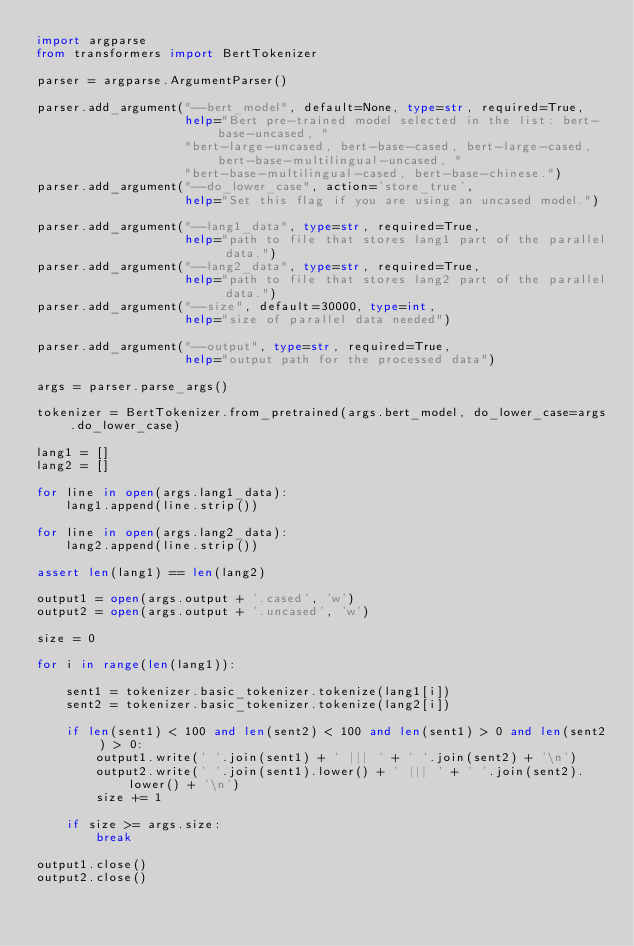Convert code to text. <code><loc_0><loc_0><loc_500><loc_500><_Python_>import argparse
from transformers import BertTokenizer

parser = argparse.ArgumentParser()

parser.add_argument("--bert_model", default=None, type=str, required=True,
                    help="Bert pre-trained model selected in the list: bert-base-uncased, "
                    "bert-large-uncased, bert-base-cased, bert-large-cased, bert-base-multilingual-uncased, "
                    "bert-base-multilingual-cased, bert-base-chinese.")
parser.add_argument("--do_lower_case", action='store_true',
                    help="Set this flag if you are using an uncased model.")

parser.add_argument("--lang1_data", type=str, required=True,
                    help="path to file that stores lang1 part of the parallel data.")
parser.add_argument("--lang2_data", type=str, required=True,
                    help="path to file that stores lang2 part of the parallel data.")
parser.add_argument("--size", default=30000, type=int,
                    help="size of parallel data needed")

parser.add_argument("--output", type=str, required=True,
                    help="output path for the processed data")

args = parser.parse_args()

tokenizer = BertTokenizer.from_pretrained(args.bert_model, do_lower_case=args.do_lower_case)

lang1 = []
lang2 = []

for line in open(args.lang1_data):
    lang1.append(line.strip())

for line in open(args.lang2_data):
    lang2.append(line.strip())

assert len(lang1) == len(lang2)

output1 = open(args.output + '.cased', 'w')
output2 = open(args.output + '.uncased', 'w')

size = 0

for i in range(len(lang1)):
    
    sent1 = tokenizer.basic_tokenizer.tokenize(lang1[i])
    sent2 = tokenizer.basic_tokenizer.tokenize(lang2[i])
    
    if len(sent1) < 100 and len(sent2) < 100 and len(sent1) > 0 and len(sent2) > 0:
        output1.write(' '.join(sent1) + ' ||| ' + ' '.join(sent2) + '\n')
        output2.write(' '.join(sent1).lower() + ' ||| ' + ' '.join(sent2).lower() + '\n')
        size += 1
        
    if size >= args.size:
        break

output1.close()
output2.close()
</code> 